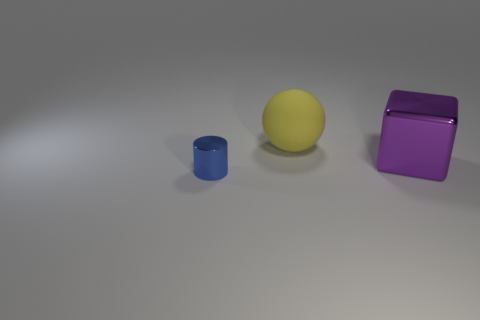Subtract all cylinders. How many objects are left? 2 Add 1 red spheres. How many objects exist? 4 Subtract 0 gray cylinders. How many objects are left? 3 Subtract all tiny objects. Subtract all big red things. How many objects are left? 2 Add 1 yellow spheres. How many yellow spheres are left? 2 Add 1 big purple blocks. How many big purple blocks exist? 2 